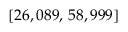Convert formula to latex. <formula><loc_0><loc_0><loc_500><loc_500>[ 2 6 , 0 8 9 , \, 5 8 , 9 9 9 ]</formula> 